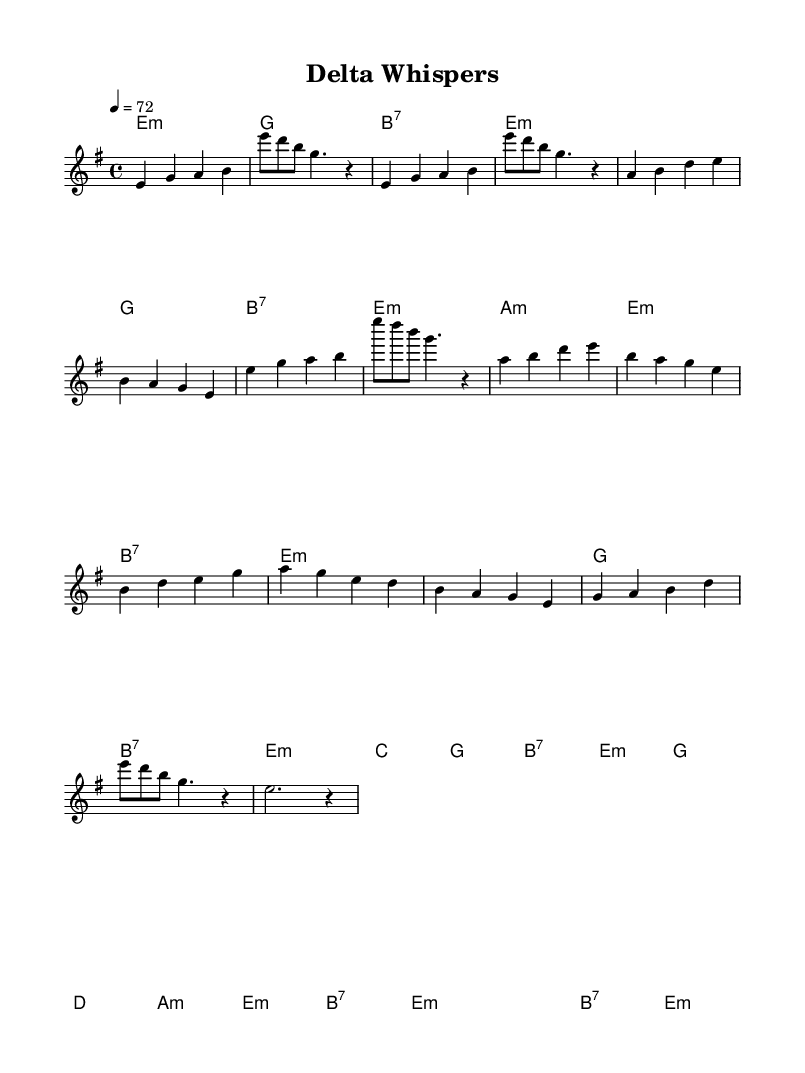What is the key signature of this music? The key signature is E minor, which has one sharp (F#). This is indicated at the beginning of the sheet music where the key signature is displayed.
Answer: E minor What is the time signature of this music? The time signature is 4/4, which means there are four beats in each measure and the quarter note gets one beat. This is shown at the beginning of the score next to the key signature.
Answer: 4/4 What is the tempo marking for this piece? The tempo marking is 72 beats per minute, indicated by the term "tempo 4 = 72." This tells the performer how fast to play the piece.
Answer: 72 How many measures are in the chorus section? The chorus section consists of 4 measures. This can be counted by looking at the melody for the chorus, which is separated into parts and each horizontal line typically represents a measure.
Answer: 4 What type of seventh chord is used in the harmonies? The harmony includes a B7 chord, indicated by "b:7" within the chord progression. This particular chord adds a richer sound typical in blues music.
Answer: B7 What musical form is primarily observed in this piece? The piece primarily follows a verse-chorus form, which is common in blues music. This can be deduced by observing the structure where the verse is followed by the repeated chorus.
Answer: Verse-chorus What is the chord used in the bridge section? The bridge section includes a G major chord, indicated by "g" within the corresponding measure of the harmonies. This chord contributes to the overall richness of the music.
Answer: G 